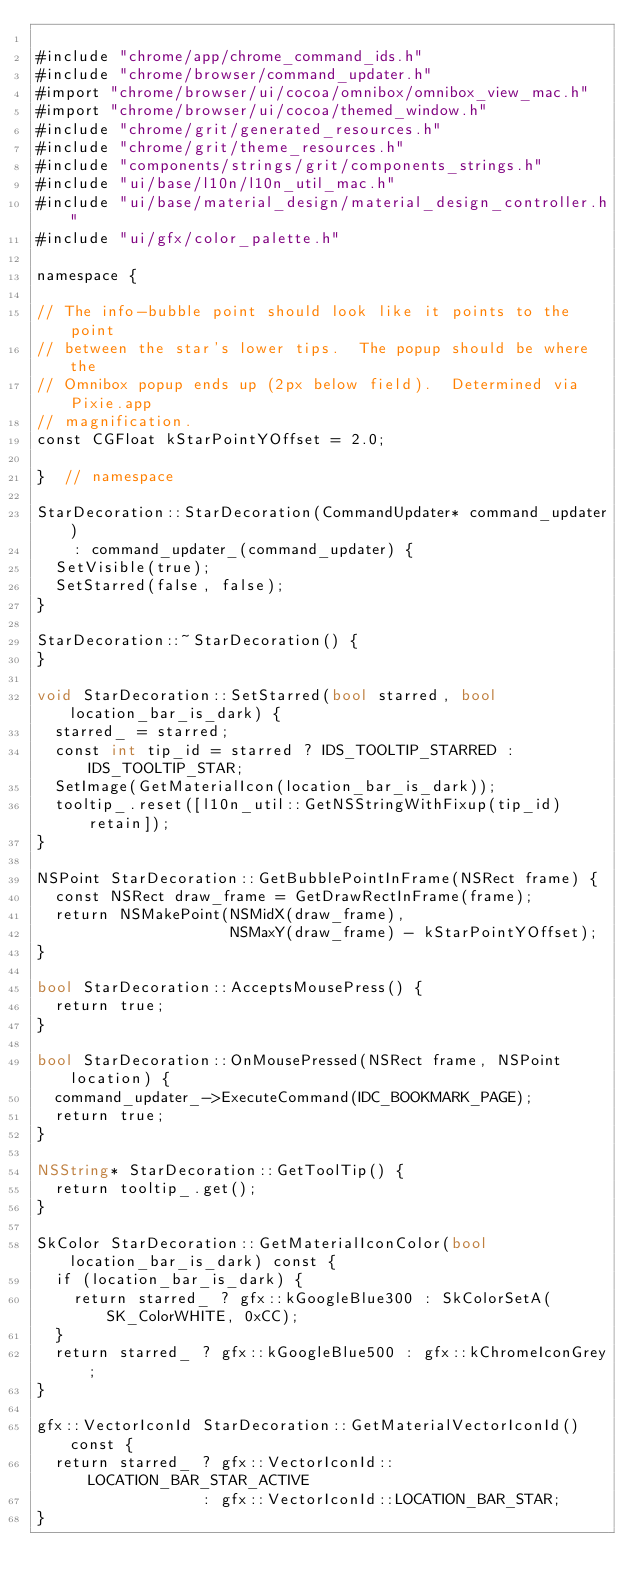Convert code to text. <code><loc_0><loc_0><loc_500><loc_500><_ObjectiveC_>
#include "chrome/app/chrome_command_ids.h"
#include "chrome/browser/command_updater.h"
#import "chrome/browser/ui/cocoa/omnibox/omnibox_view_mac.h"
#import "chrome/browser/ui/cocoa/themed_window.h"
#include "chrome/grit/generated_resources.h"
#include "chrome/grit/theme_resources.h"
#include "components/strings/grit/components_strings.h"
#include "ui/base/l10n/l10n_util_mac.h"
#include "ui/base/material_design/material_design_controller.h"
#include "ui/gfx/color_palette.h"

namespace {

// The info-bubble point should look like it points to the point
// between the star's lower tips.  The popup should be where the
// Omnibox popup ends up (2px below field).  Determined via Pixie.app
// magnification.
const CGFloat kStarPointYOffset = 2.0;

}  // namespace

StarDecoration::StarDecoration(CommandUpdater* command_updater)
    : command_updater_(command_updater) {
  SetVisible(true);
  SetStarred(false, false);
}

StarDecoration::~StarDecoration() {
}

void StarDecoration::SetStarred(bool starred, bool location_bar_is_dark) {
  starred_ = starred;
  const int tip_id = starred ? IDS_TOOLTIP_STARRED : IDS_TOOLTIP_STAR;
  SetImage(GetMaterialIcon(location_bar_is_dark));
  tooltip_.reset([l10n_util::GetNSStringWithFixup(tip_id) retain]);
}

NSPoint StarDecoration::GetBubblePointInFrame(NSRect frame) {
  const NSRect draw_frame = GetDrawRectInFrame(frame);
  return NSMakePoint(NSMidX(draw_frame),
                     NSMaxY(draw_frame) - kStarPointYOffset);
}

bool StarDecoration::AcceptsMousePress() {
  return true;
}

bool StarDecoration::OnMousePressed(NSRect frame, NSPoint location) {
  command_updater_->ExecuteCommand(IDC_BOOKMARK_PAGE);
  return true;
}

NSString* StarDecoration::GetToolTip() {
  return tooltip_.get();
}

SkColor StarDecoration::GetMaterialIconColor(bool location_bar_is_dark) const {
  if (location_bar_is_dark) {
    return starred_ ? gfx::kGoogleBlue300 : SkColorSetA(SK_ColorWHITE, 0xCC);
  }
  return starred_ ? gfx::kGoogleBlue500 : gfx::kChromeIconGrey;
}

gfx::VectorIconId StarDecoration::GetMaterialVectorIconId() const {
  return starred_ ? gfx::VectorIconId::LOCATION_BAR_STAR_ACTIVE
                  : gfx::VectorIconId::LOCATION_BAR_STAR;
}
</code> 